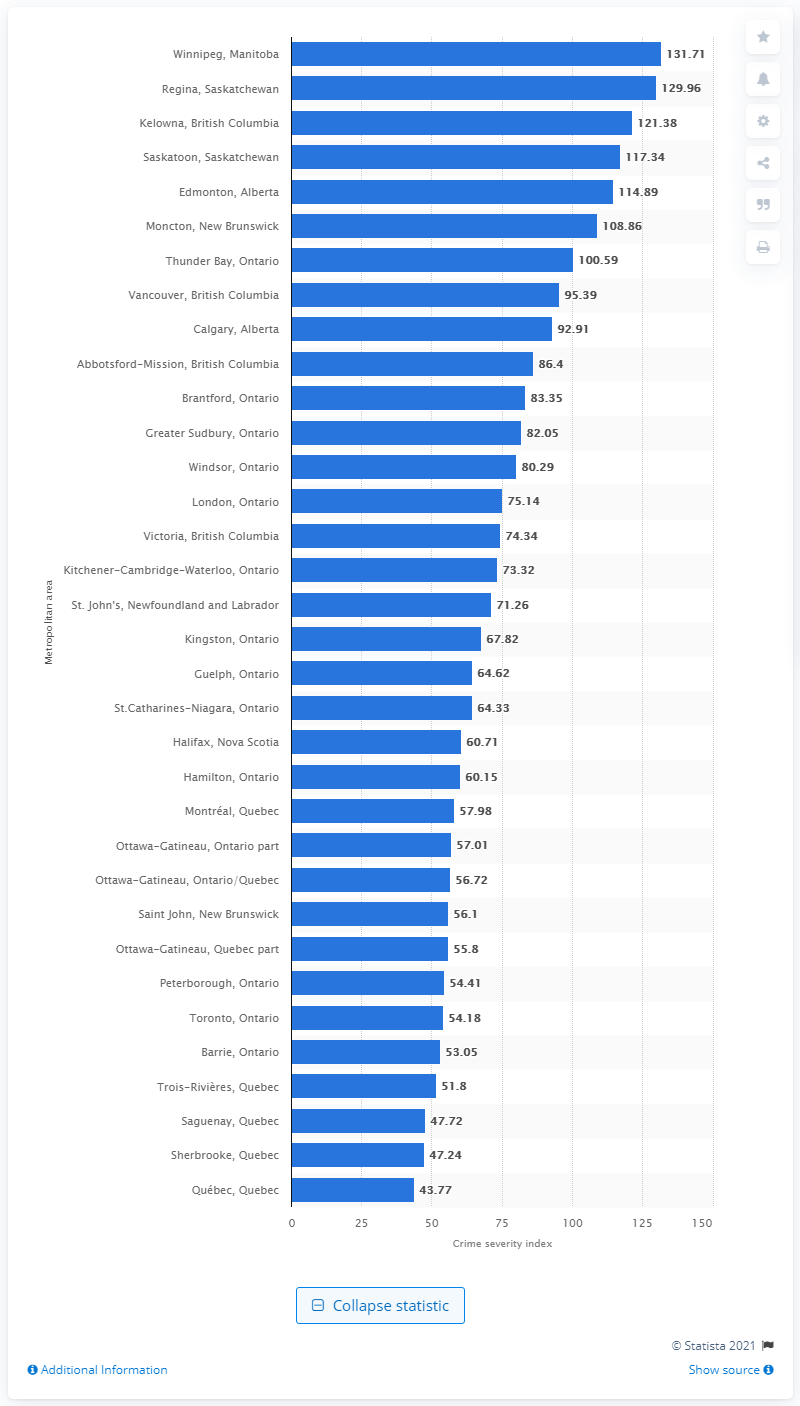Indicate a few pertinent items in this graphic. In 2019, the crime severity index in Saskatoon, Saskatchewan was 117.34, which indicates a higher level of crime compared to the national average. 